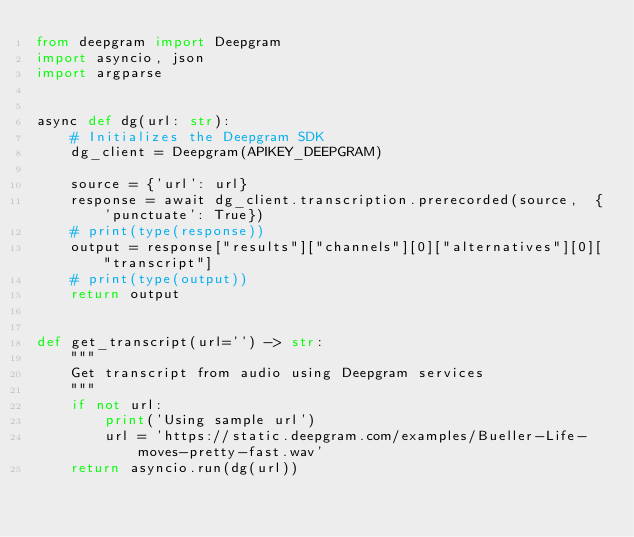Convert code to text. <code><loc_0><loc_0><loc_500><loc_500><_Python_>from deepgram import Deepgram
import asyncio, json
import argparse


async def dg(url: str):
    # Initializes the Deepgram SDK
    dg_client = Deepgram(APIKEY_DEEPGRAM)

    source = {'url': url}
    response = await dg_client.transcription.prerecorded(source,  {'punctuate': True})
    # print(type(response))
    output = response["results"]["channels"][0]["alternatives"][0]["transcript"]
    # print(type(output))
    return output


def get_transcript(url='') -> str:
    """
    Get transcript from audio using Deepgram services
    """
    if not url:
        print('Using sample url')
        url = 'https://static.deepgram.com/examples/Bueller-Life-moves-pretty-fast.wav'
    return asyncio.run(dg(url))

</code> 